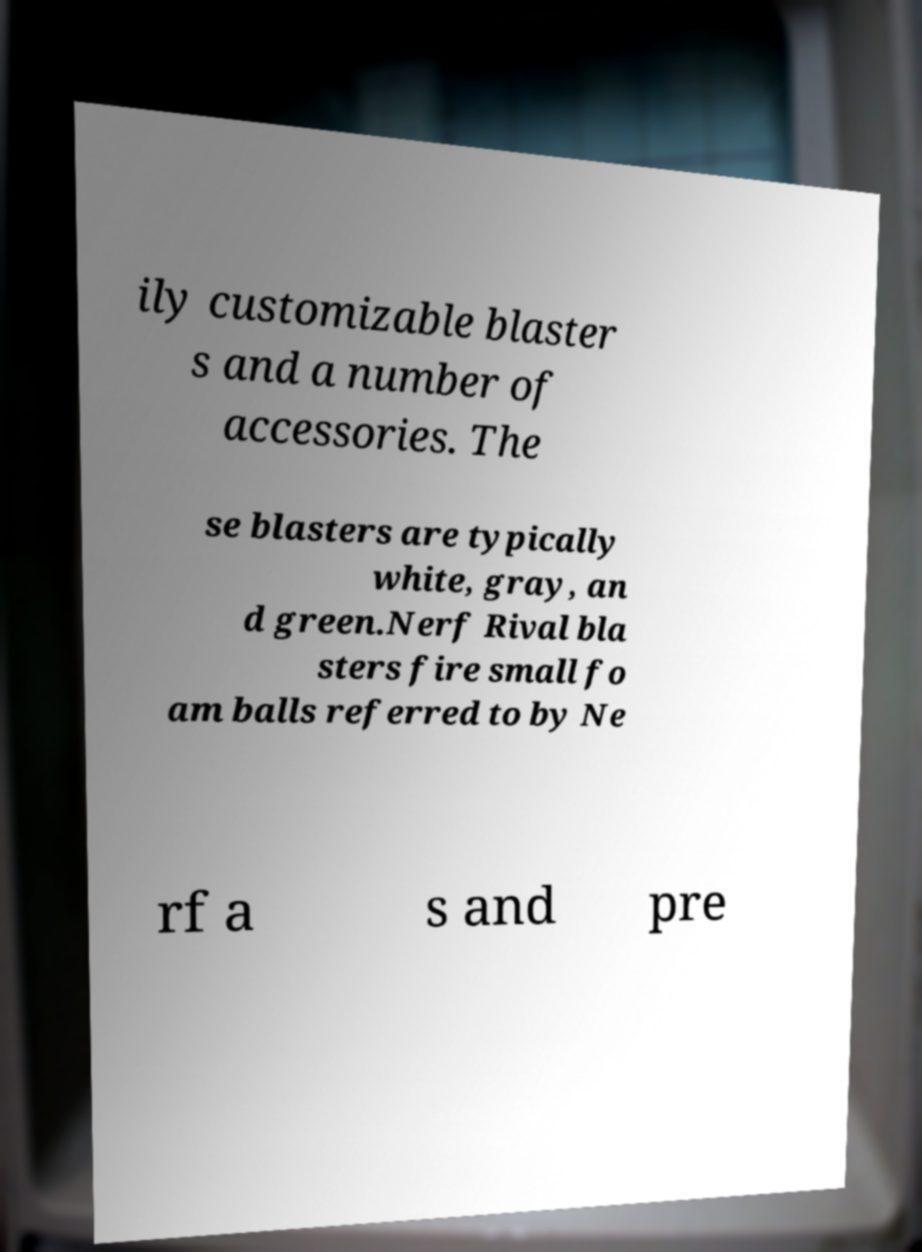What messages or text are displayed in this image? I need them in a readable, typed format. ily customizable blaster s and a number of accessories. The se blasters are typically white, gray, an d green.Nerf Rival bla sters fire small fo am balls referred to by Ne rf a s and pre 